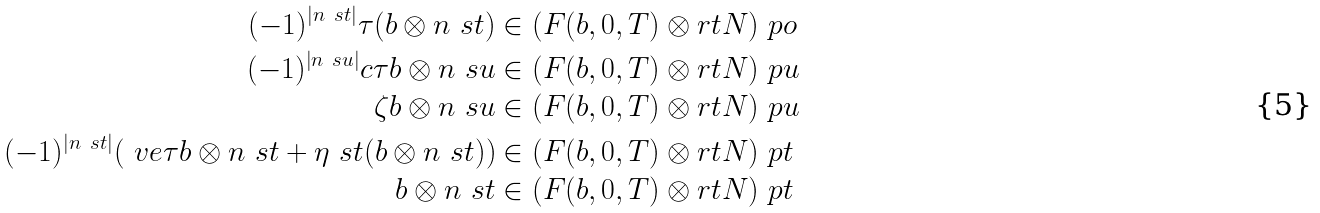Convert formula to latex. <formula><loc_0><loc_0><loc_500><loc_500>( - 1 ) ^ { | n \ s t | } \tau ( b \otimes n \ s t ) & \in ( F ( b , 0 , T ) \otimes r t N ) \ p o \\ ( - 1 ) ^ { | n \ s u | } c \tau b \otimes n \ s u & \in ( F ( b , 0 , T ) \otimes r t N ) \ p u \\ \zeta b \otimes n \ s u & \in ( F ( b , 0 , T ) \otimes r t N ) \ p u \\ ( - 1 ) ^ { | n \ s t | } ( \ v e \tau b \otimes n \ s t + \eta \ s t ( b \otimes n \ s t ) ) & \in ( F ( b , 0 , T ) \otimes r t N ) \ p t \\ b \otimes n \ s t & \in ( F ( b , 0 , T ) \otimes r t N ) \ p t</formula> 